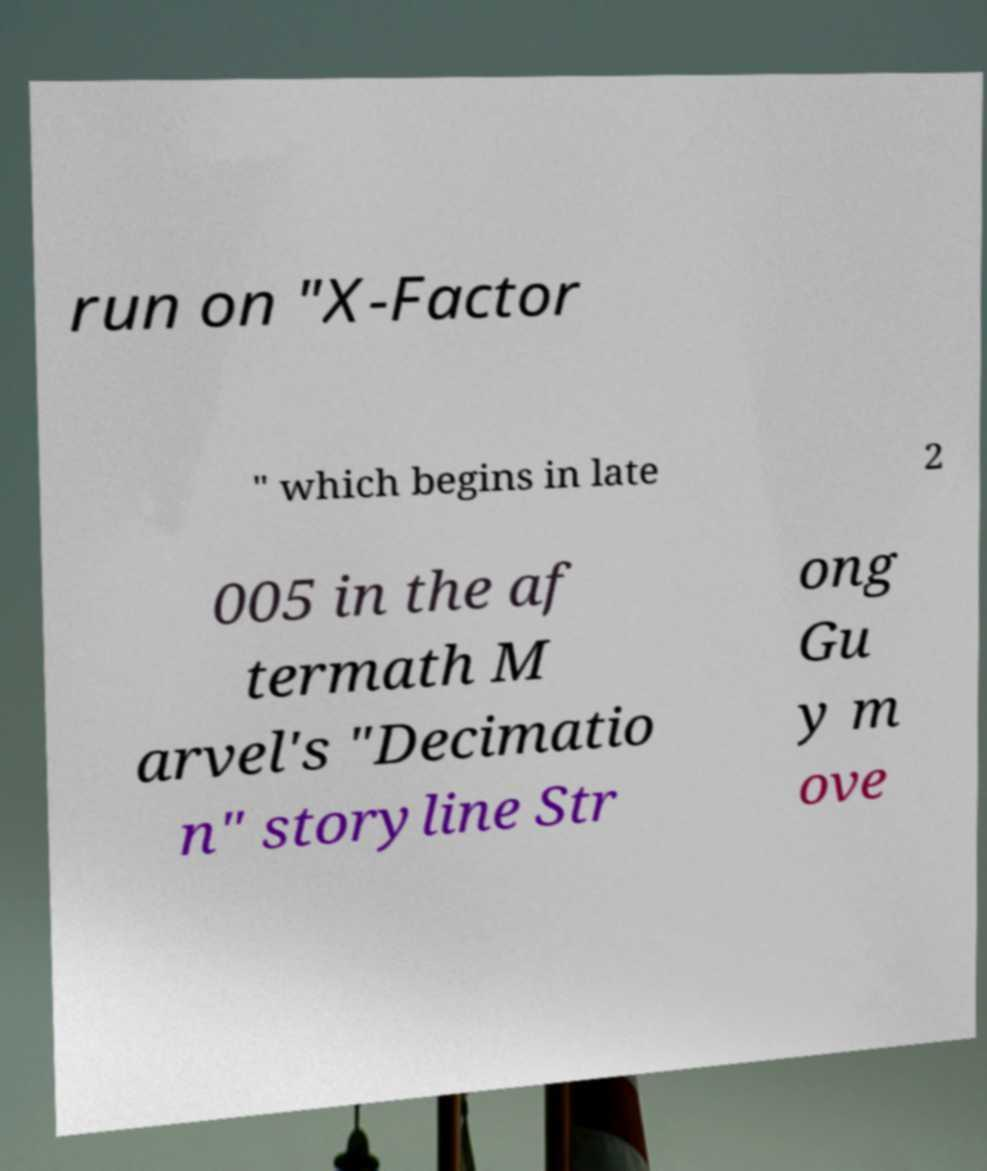Can you read and provide the text displayed in the image?This photo seems to have some interesting text. Can you extract and type it out for me? run on "X-Factor " which begins in late 2 005 in the af termath M arvel's "Decimatio n" storyline Str ong Gu y m ove 